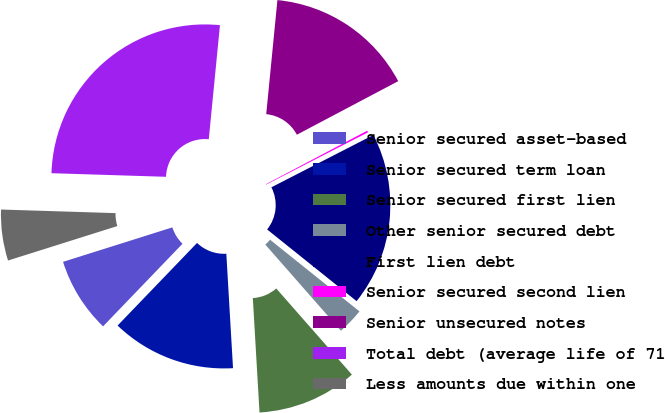Convert chart to OTSL. <chart><loc_0><loc_0><loc_500><loc_500><pie_chart><fcel>Senior secured asset-based<fcel>Senior secured term loan<fcel>Senior secured first lien<fcel>Other senior secured debt<fcel>First lien debt<fcel>Senior secured second lien<fcel>Senior unsecured notes<fcel>Total debt (average life of 71<fcel>Less amounts due within one<nl><fcel>7.95%<fcel>13.12%<fcel>10.54%<fcel>2.78%<fcel>18.3%<fcel>0.19%<fcel>15.71%<fcel>26.06%<fcel>5.36%<nl></chart> 